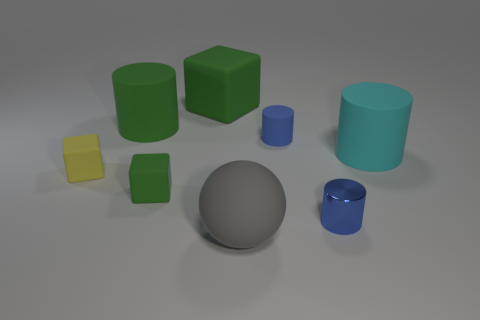Subtract all tiny matte cylinders. How many cylinders are left? 3 Subtract all gray cylinders. How many green blocks are left? 2 Add 1 small blue metal things. How many objects exist? 9 Subtract 1 cylinders. How many cylinders are left? 3 Subtract all cubes. How many objects are left? 5 Subtract all yellow cubes. How many cubes are left? 2 Subtract all red cylinders. Subtract all gray spheres. How many cylinders are left? 4 Subtract all large gray matte spheres. Subtract all green cylinders. How many objects are left? 6 Add 5 green blocks. How many green blocks are left? 7 Add 8 green rubber cubes. How many green rubber cubes exist? 10 